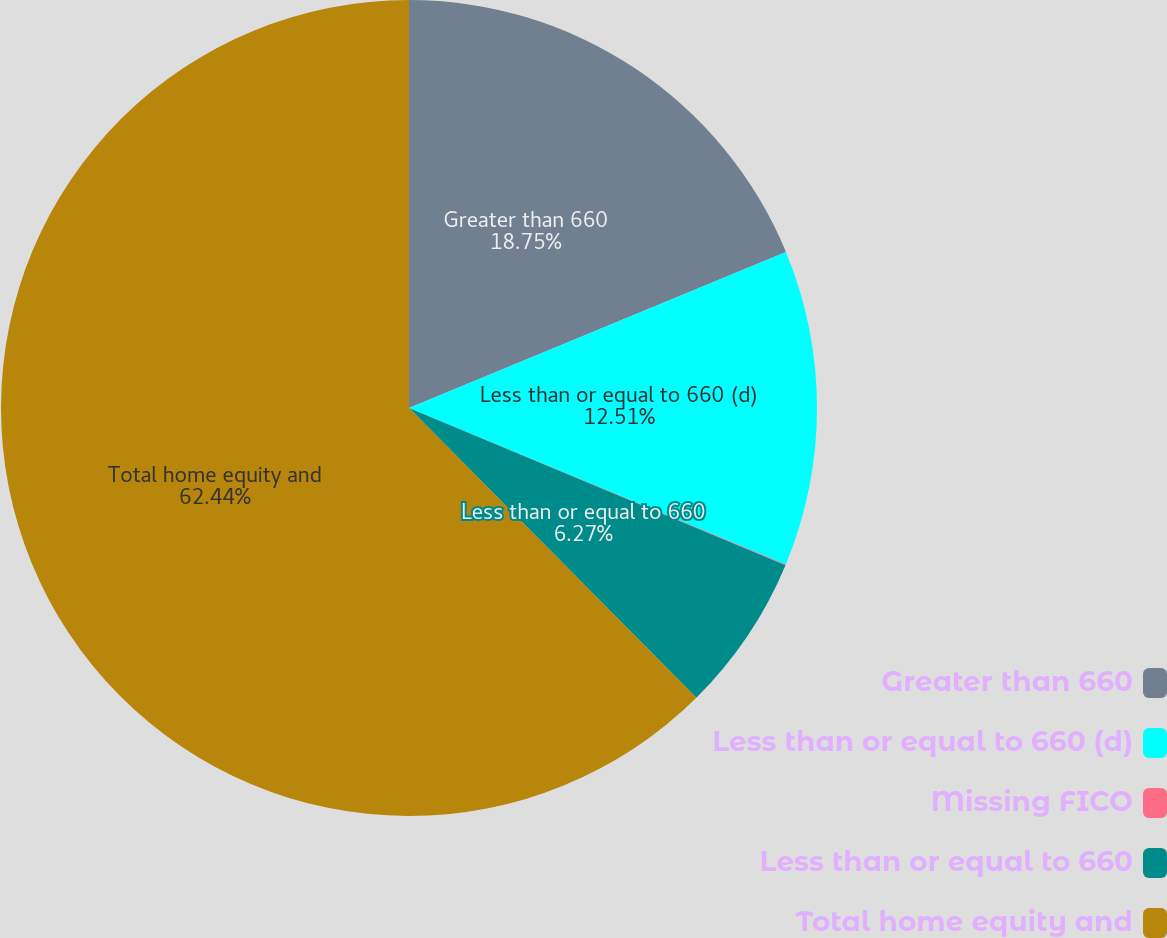<chart> <loc_0><loc_0><loc_500><loc_500><pie_chart><fcel>Greater than 660<fcel>Less than or equal to 660 (d)<fcel>Missing FICO<fcel>Less than or equal to 660<fcel>Total home equity and<nl><fcel>18.75%<fcel>12.51%<fcel>0.03%<fcel>6.27%<fcel>62.43%<nl></chart> 